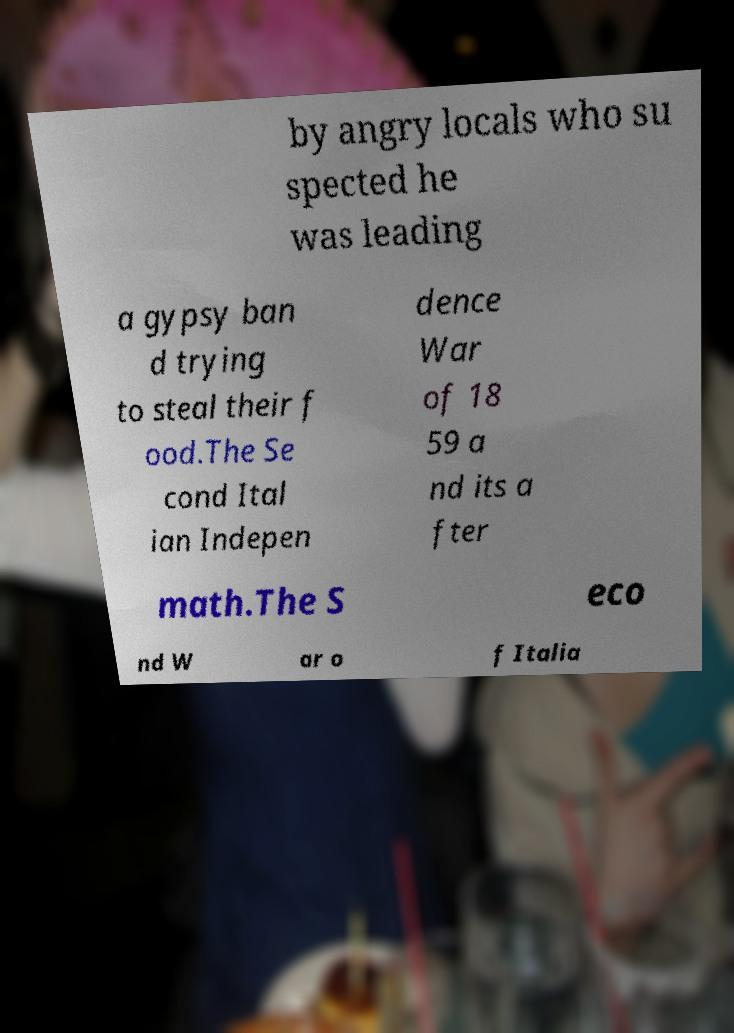There's text embedded in this image that I need extracted. Can you transcribe it verbatim? by angry locals who su spected he was leading a gypsy ban d trying to steal their f ood.The Se cond Ital ian Indepen dence War of 18 59 a nd its a fter math.The S eco nd W ar o f Italia 